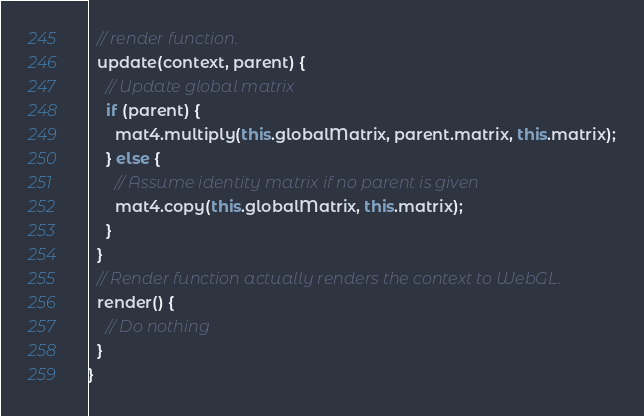Convert code to text. <code><loc_0><loc_0><loc_500><loc_500><_JavaScript_>  // render function.
  update(context, parent) {
    // Update global matrix
    if (parent) {
      mat4.multiply(this.globalMatrix, parent.matrix, this.matrix);
    } else {
      // Assume identity matrix if no parent is given
      mat4.copy(this.globalMatrix, this.matrix);
    }
  }
  // Render function actually renders the context to WebGL.
  render() {
    // Do nothing
  }
}
</code> 